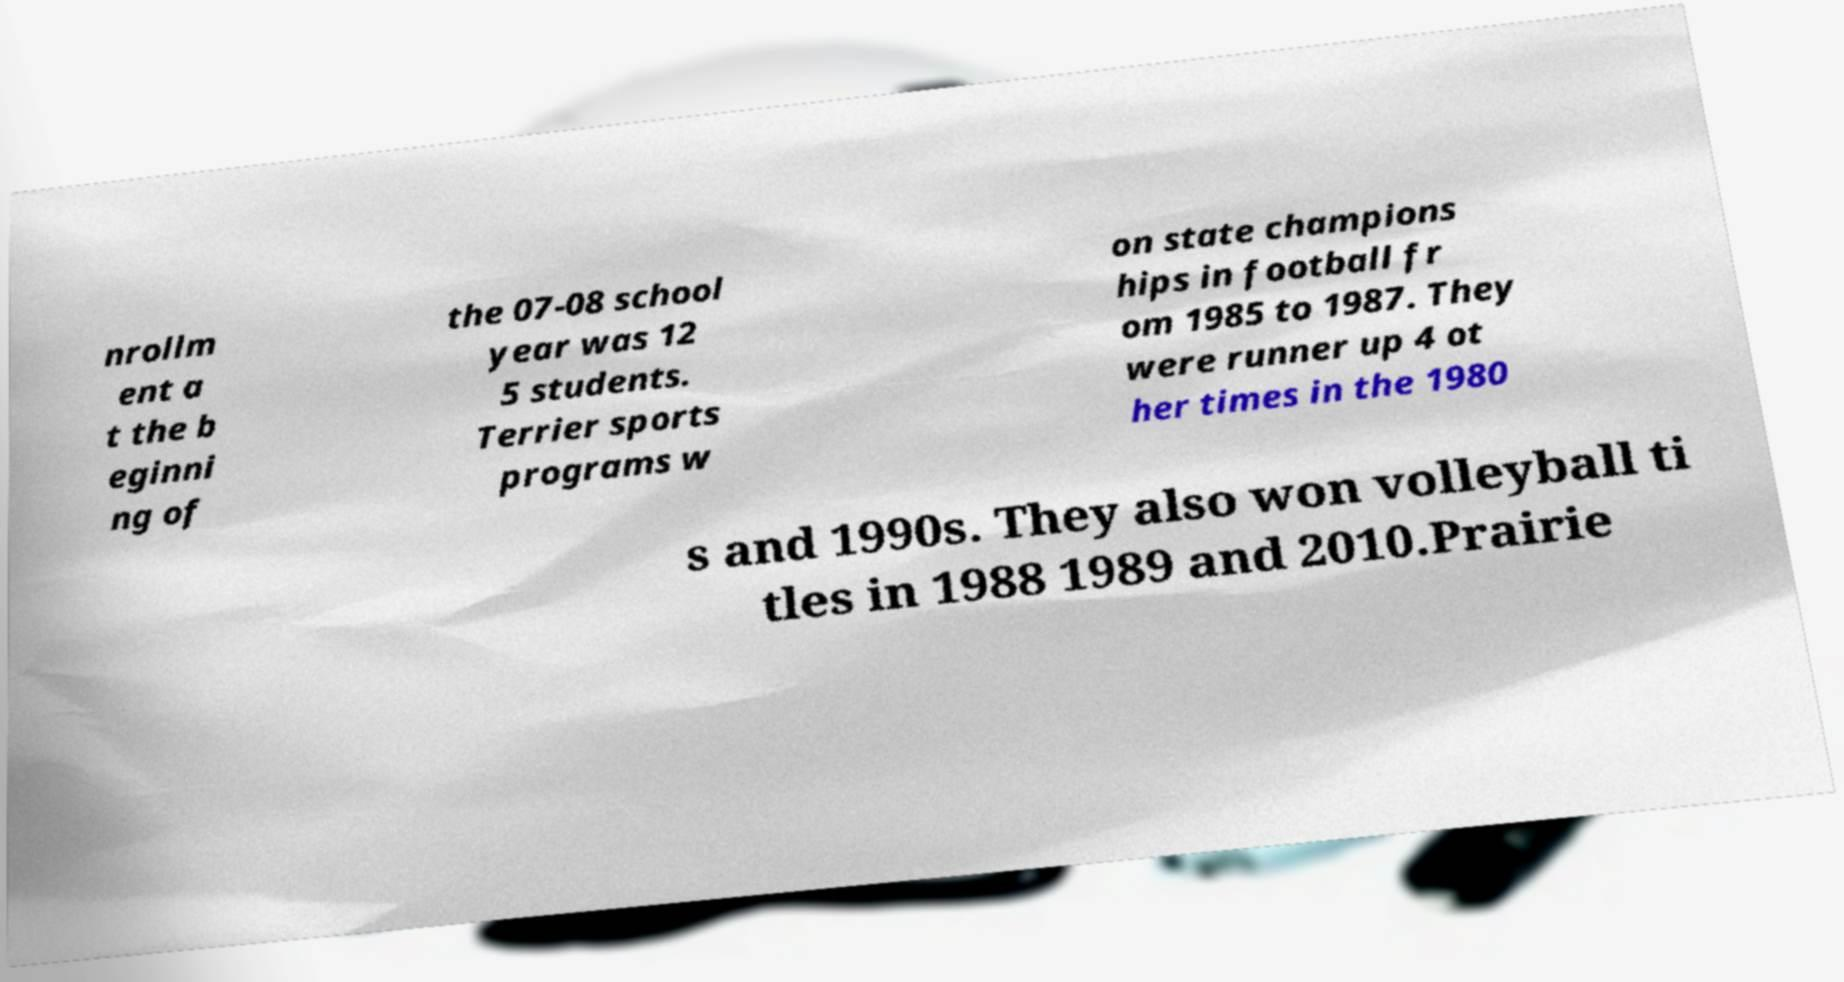Please identify and transcribe the text found in this image. nrollm ent a t the b eginni ng of the 07-08 school year was 12 5 students. Terrier sports programs w on state champions hips in football fr om 1985 to 1987. They were runner up 4 ot her times in the 1980 s and 1990s. They also won volleyball ti tles in 1988 1989 and 2010.Prairie 